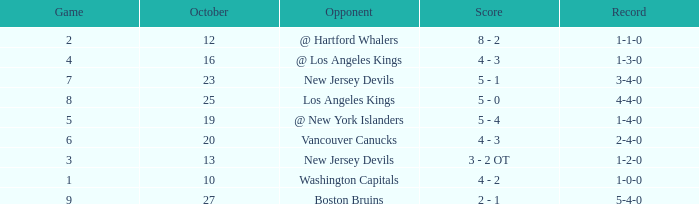What was the average game with a record of 4-4-0? 8.0. Parse the full table. {'header': ['Game', 'October', 'Opponent', 'Score', 'Record'], 'rows': [['2', '12', '@ Hartford Whalers', '8 - 2', '1-1-0'], ['4', '16', '@ Los Angeles Kings', '4 - 3', '1-3-0'], ['7', '23', 'New Jersey Devils', '5 - 1', '3-4-0'], ['8', '25', 'Los Angeles Kings', '5 - 0', '4-4-0'], ['5', '19', '@ New York Islanders', '5 - 4', '1-4-0'], ['6', '20', 'Vancouver Canucks', '4 - 3', '2-4-0'], ['3', '13', 'New Jersey Devils', '3 - 2 OT', '1-2-0'], ['1', '10', 'Washington Capitals', '4 - 2', '1-0-0'], ['9', '27', 'Boston Bruins', '2 - 1', '5-4-0']]} 